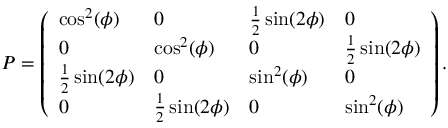Convert formula to latex. <formula><loc_0><loc_0><loc_500><loc_500>\begin{array} { r } { P = \left ( \begin{array} { l l l l } { \cos ^ { 2 } ( \phi ) } & { 0 } & { \frac { 1 } { 2 } \sin ( 2 \phi ) } & { 0 } \\ { 0 } & { \cos ^ { 2 } ( \phi ) } & { 0 } & { \frac { 1 } { 2 } \sin ( 2 \phi ) } \\ { \frac { 1 } { 2 } \sin ( 2 \phi ) } & { 0 } & { \sin ^ { 2 } ( \phi ) } & { 0 } \\ { 0 } & { \frac { 1 } { 2 } \sin ( 2 \phi ) } & { 0 } & { \sin ^ { 2 } ( \phi ) } \end{array} \right ) . } \end{array}</formula> 